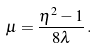<formula> <loc_0><loc_0><loc_500><loc_500>\mu = \frac { \eta ^ { 2 } - 1 } { 8 \lambda } \, .</formula> 